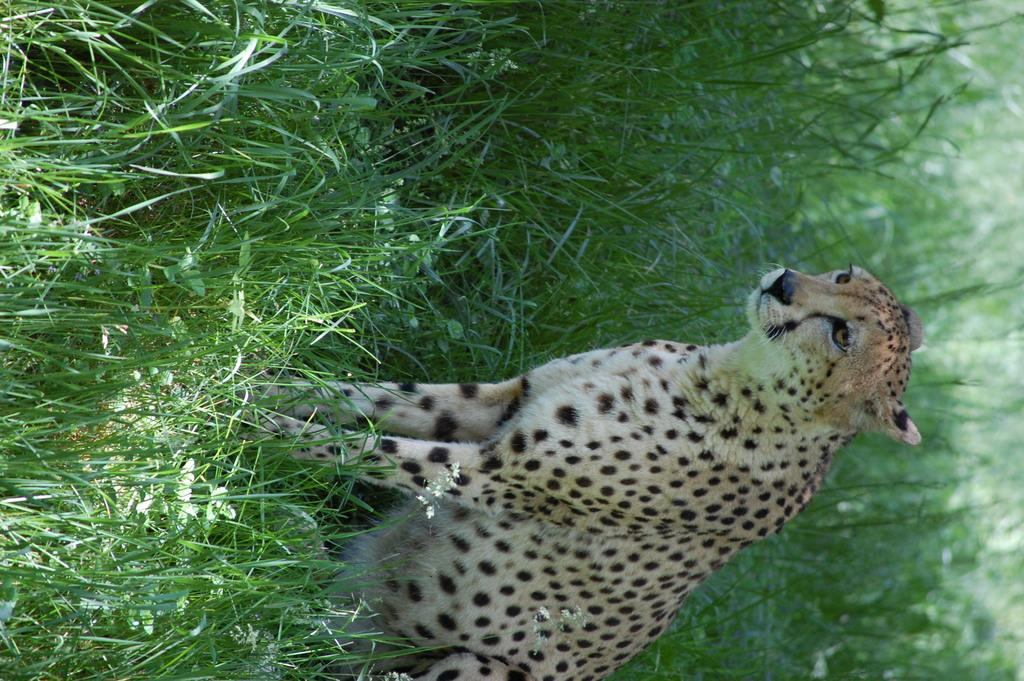What is the main subject in the center of the image? There is a leopard in the center of the image. What else can be seen in the image besides the leopard? There are plants in the image. What type of locket is the leopard wearing around its neck in the image? There is no locket visible around the leopard's neck in the image. What memory does the leopard seem to be recalling in the image? The image does not provide any information about the leopard's thoughts or memories. 